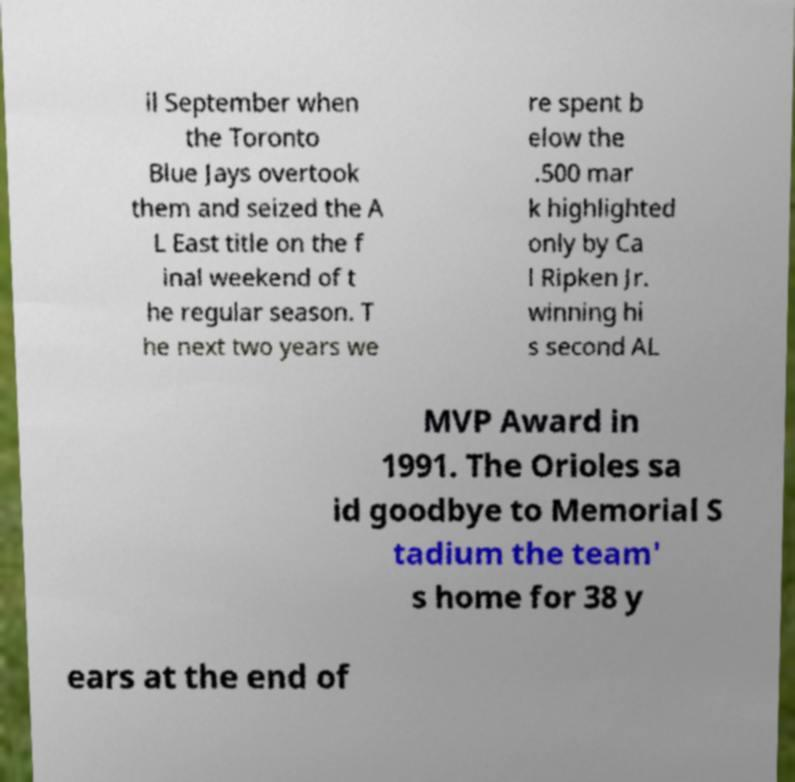What messages or text are displayed in this image? I need them in a readable, typed format. il September when the Toronto Blue Jays overtook them and seized the A L East title on the f inal weekend of t he regular season. T he next two years we re spent b elow the .500 mar k highlighted only by Ca l Ripken Jr. winning hi s second AL MVP Award in 1991. The Orioles sa id goodbye to Memorial S tadium the team' s home for 38 y ears at the end of 